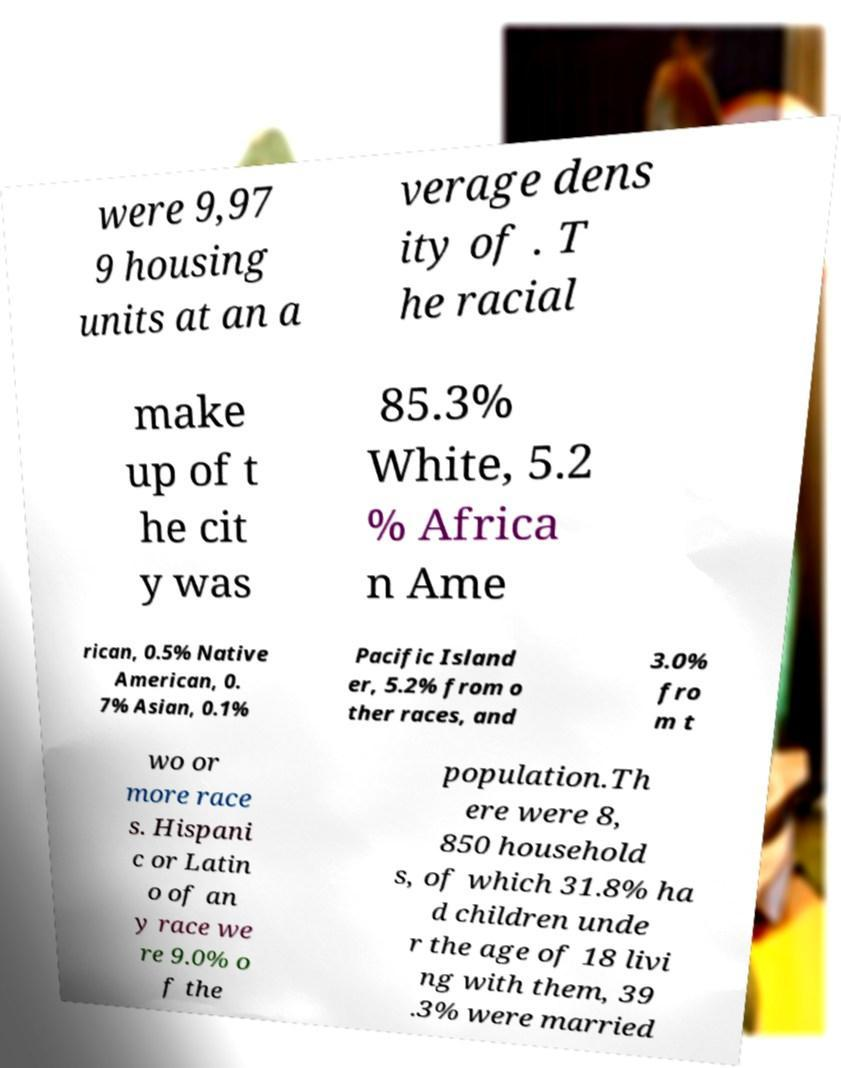Could you assist in decoding the text presented in this image and type it out clearly? were 9,97 9 housing units at an a verage dens ity of . T he racial make up of t he cit y was 85.3% White, 5.2 % Africa n Ame rican, 0.5% Native American, 0. 7% Asian, 0.1% Pacific Island er, 5.2% from o ther races, and 3.0% fro m t wo or more race s. Hispani c or Latin o of an y race we re 9.0% o f the population.Th ere were 8, 850 household s, of which 31.8% ha d children unde r the age of 18 livi ng with them, 39 .3% were married 